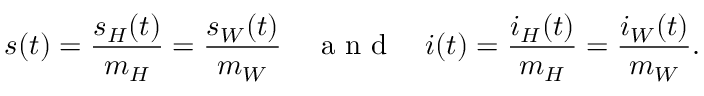Convert formula to latex. <formula><loc_0><loc_0><loc_500><loc_500>s ( t ) = \frac { s _ { H } ( t ) } { m _ { H } } = \frac { s _ { W } ( t ) } { m _ { W } } \quad a n d \quad i ( t ) = \frac { i _ { H } ( t ) } { m _ { H } } = \frac { i _ { W } ( t ) } { m _ { W } } .</formula> 